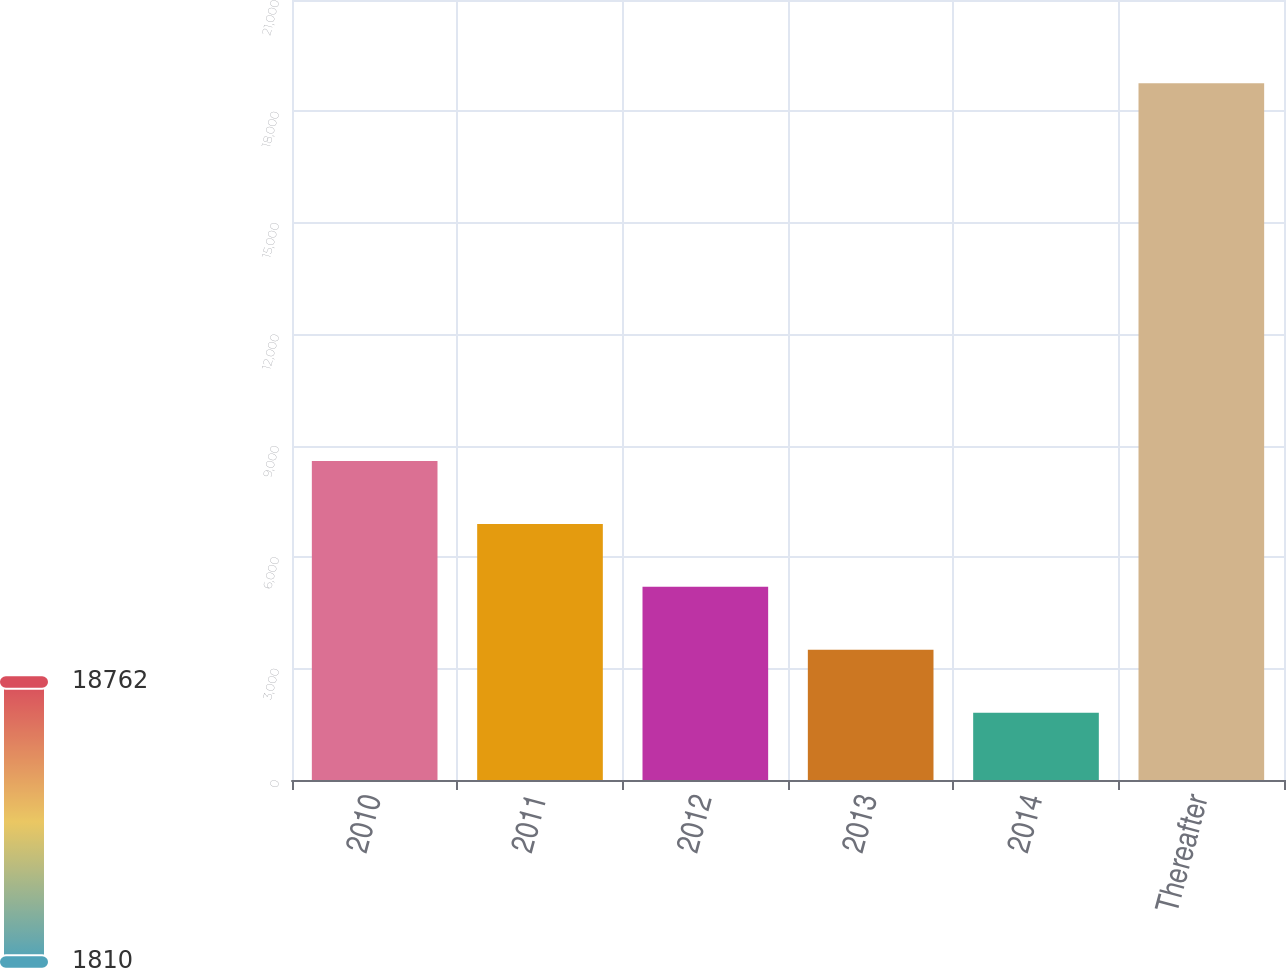<chart> <loc_0><loc_0><loc_500><loc_500><bar_chart><fcel>2010<fcel>2011<fcel>2012<fcel>2013<fcel>2014<fcel>Thereafter<nl><fcel>8590.8<fcel>6895.6<fcel>5200.4<fcel>3505.2<fcel>1810<fcel>18762<nl></chart> 